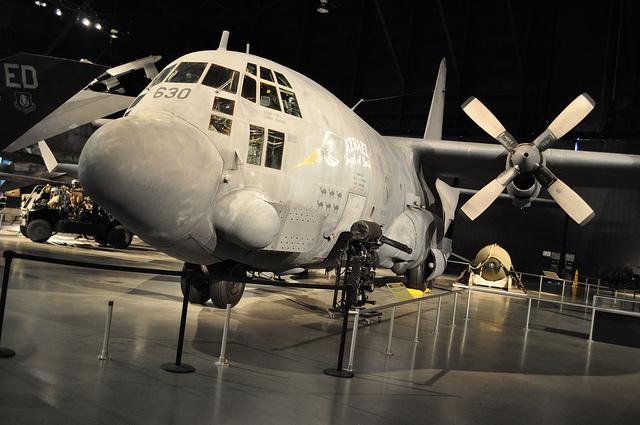What number is on the plane?
Write a very short answer. 630. Are there planes hanging from the ceiling?
Be succinct. No. Is this a propeller plane?
Answer briefly. Yes. Where are the numbers 630?
Keep it brief. Front of plane. How many windows are visible?
Short answer required. 13. 